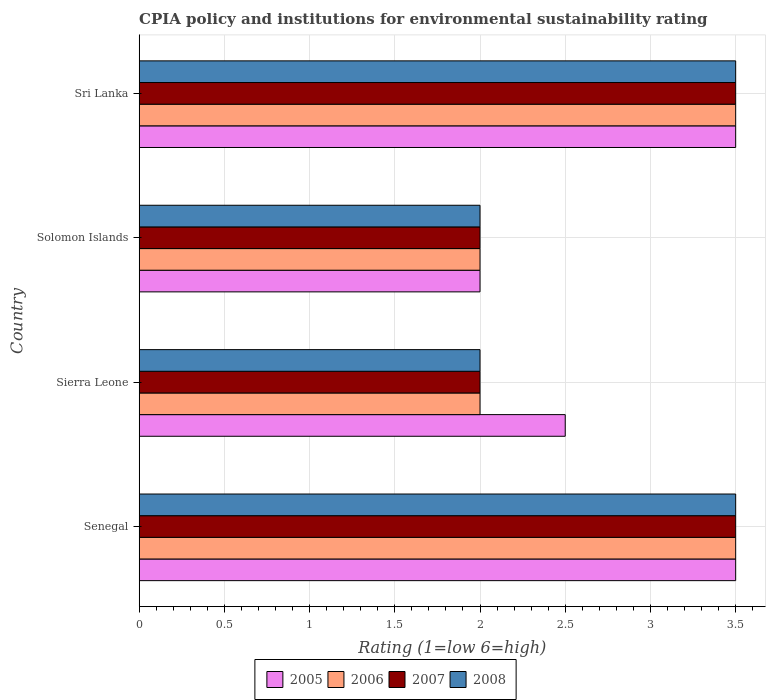How many groups of bars are there?
Give a very brief answer. 4. Are the number of bars per tick equal to the number of legend labels?
Your answer should be very brief. Yes. Are the number of bars on each tick of the Y-axis equal?
Your answer should be compact. Yes. How many bars are there on the 4th tick from the top?
Your response must be concise. 4. How many bars are there on the 4th tick from the bottom?
Give a very brief answer. 4. What is the label of the 4th group of bars from the top?
Ensure brevity in your answer.  Senegal. Across all countries, what is the maximum CPIA rating in 2005?
Offer a terse response. 3.5. In which country was the CPIA rating in 2006 maximum?
Provide a succinct answer. Senegal. In which country was the CPIA rating in 2008 minimum?
Offer a terse response. Sierra Leone. What is the total CPIA rating in 2006 in the graph?
Keep it short and to the point. 11. What is the difference between the CPIA rating in 2008 in Senegal and that in Solomon Islands?
Offer a terse response. 1.5. What is the difference between the CPIA rating in 2006 in Solomon Islands and the CPIA rating in 2008 in Senegal?
Ensure brevity in your answer.  -1.5. What is the average CPIA rating in 2005 per country?
Your answer should be compact. 2.88. What is the difference between the CPIA rating in 2008 and CPIA rating in 2007 in Solomon Islands?
Make the answer very short. 0. In how many countries, is the CPIA rating in 2005 greater than 3.4 ?
Your response must be concise. 2. What is the ratio of the CPIA rating in 2005 in Solomon Islands to that in Sri Lanka?
Offer a terse response. 0.57. Is the difference between the CPIA rating in 2008 in Sierra Leone and Solomon Islands greater than the difference between the CPIA rating in 2007 in Sierra Leone and Solomon Islands?
Make the answer very short. No. What is the difference between the highest and the second highest CPIA rating in 2007?
Offer a terse response. 0. Is the sum of the CPIA rating in 2005 in Senegal and Sierra Leone greater than the maximum CPIA rating in 2006 across all countries?
Provide a succinct answer. Yes. What does the 4th bar from the bottom in Senegal represents?
Ensure brevity in your answer.  2008. How many bars are there?
Your answer should be very brief. 16. Are all the bars in the graph horizontal?
Offer a very short reply. Yes. How many countries are there in the graph?
Keep it short and to the point. 4. What is the difference between two consecutive major ticks on the X-axis?
Give a very brief answer. 0.5. Are the values on the major ticks of X-axis written in scientific E-notation?
Offer a terse response. No. How many legend labels are there?
Ensure brevity in your answer.  4. How are the legend labels stacked?
Provide a short and direct response. Horizontal. What is the title of the graph?
Keep it short and to the point. CPIA policy and institutions for environmental sustainability rating. Does "1987" appear as one of the legend labels in the graph?
Provide a short and direct response. No. What is the label or title of the X-axis?
Provide a short and direct response. Rating (1=low 6=high). What is the Rating (1=low 6=high) in 2005 in Senegal?
Your response must be concise. 3.5. What is the Rating (1=low 6=high) in 2006 in Senegal?
Provide a succinct answer. 3.5. What is the Rating (1=low 6=high) in 2008 in Senegal?
Your answer should be compact. 3.5. What is the Rating (1=low 6=high) of 2005 in Solomon Islands?
Provide a succinct answer. 2. What is the Rating (1=low 6=high) of 2005 in Sri Lanka?
Provide a short and direct response. 3.5. What is the Rating (1=low 6=high) in 2007 in Sri Lanka?
Give a very brief answer. 3.5. What is the Rating (1=low 6=high) of 2008 in Sri Lanka?
Provide a succinct answer. 3.5. Across all countries, what is the maximum Rating (1=low 6=high) in 2008?
Provide a short and direct response. 3.5. Across all countries, what is the minimum Rating (1=low 6=high) of 2006?
Your answer should be compact. 2. Across all countries, what is the minimum Rating (1=low 6=high) in 2007?
Offer a terse response. 2. What is the total Rating (1=low 6=high) in 2005 in the graph?
Your answer should be compact. 11.5. What is the total Rating (1=low 6=high) of 2006 in the graph?
Give a very brief answer. 11. What is the total Rating (1=low 6=high) of 2007 in the graph?
Offer a terse response. 11. What is the total Rating (1=low 6=high) of 2008 in the graph?
Keep it short and to the point. 11. What is the difference between the Rating (1=low 6=high) of 2008 in Senegal and that in Sierra Leone?
Provide a short and direct response. 1.5. What is the difference between the Rating (1=low 6=high) of 2005 in Senegal and that in Solomon Islands?
Make the answer very short. 1.5. What is the difference between the Rating (1=low 6=high) of 2007 in Senegal and that in Solomon Islands?
Provide a short and direct response. 1.5. What is the difference between the Rating (1=low 6=high) in 2008 in Senegal and that in Solomon Islands?
Your answer should be very brief. 1.5. What is the difference between the Rating (1=low 6=high) of 2007 in Senegal and that in Sri Lanka?
Give a very brief answer. 0. What is the difference between the Rating (1=low 6=high) in 2008 in Senegal and that in Sri Lanka?
Offer a very short reply. 0. What is the difference between the Rating (1=low 6=high) in 2006 in Sierra Leone and that in Solomon Islands?
Give a very brief answer. 0. What is the difference between the Rating (1=low 6=high) of 2007 in Sierra Leone and that in Solomon Islands?
Ensure brevity in your answer.  0. What is the difference between the Rating (1=low 6=high) of 2006 in Sierra Leone and that in Sri Lanka?
Provide a succinct answer. -1.5. What is the difference between the Rating (1=low 6=high) in 2008 in Sierra Leone and that in Sri Lanka?
Give a very brief answer. -1.5. What is the difference between the Rating (1=low 6=high) of 2006 in Solomon Islands and that in Sri Lanka?
Ensure brevity in your answer.  -1.5. What is the difference between the Rating (1=low 6=high) of 2007 in Solomon Islands and that in Sri Lanka?
Ensure brevity in your answer.  -1.5. What is the difference between the Rating (1=low 6=high) in 2005 in Senegal and the Rating (1=low 6=high) in 2006 in Sierra Leone?
Offer a very short reply. 1.5. What is the difference between the Rating (1=low 6=high) of 2005 in Senegal and the Rating (1=low 6=high) of 2008 in Sierra Leone?
Your answer should be very brief. 1.5. What is the difference between the Rating (1=low 6=high) of 2006 in Senegal and the Rating (1=low 6=high) of 2007 in Sierra Leone?
Provide a short and direct response. 1.5. What is the difference between the Rating (1=low 6=high) in 2007 in Senegal and the Rating (1=low 6=high) in 2008 in Sierra Leone?
Ensure brevity in your answer.  1.5. What is the difference between the Rating (1=low 6=high) in 2005 in Senegal and the Rating (1=low 6=high) in 2007 in Solomon Islands?
Your answer should be compact. 1.5. What is the difference between the Rating (1=low 6=high) in 2006 in Senegal and the Rating (1=low 6=high) in 2008 in Solomon Islands?
Make the answer very short. 1.5. What is the difference between the Rating (1=low 6=high) of 2007 in Senegal and the Rating (1=low 6=high) of 2008 in Solomon Islands?
Your response must be concise. 1.5. What is the difference between the Rating (1=low 6=high) of 2005 in Senegal and the Rating (1=low 6=high) of 2008 in Sri Lanka?
Give a very brief answer. 0. What is the difference between the Rating (1=low 6=high) in 2005 in Sierra Leone and the Rating (1=low 6=high) in 2006 in Solomon Islands?
Provide a short and direct response. 0.5. What is the difference between the Rating (1=low 6=high) in 2006 in Sierra Leone and the Rating (1=low 6=high) in 2008 in Solomon Islands?
Offer a terse response. 0. What is the difference between the Rating (1=low 6=high) in 2007 in Sierra Leone and the Rating (1=low 6=high) in 2008 in Solomon Islands?
Give a very brief answer. 0. What is the difference between the Rating (1=low 6=high) in 2006 in Sierra Leone and the Rating (1=low 6=high) in 2007 in Sri Lanka?
Offer a terse response. -1.5. What is the difference between the Rating (1=low 6=high) of 2006 in Sierra Leone and the Rating (1=low 6=high) of 2008 in Sri Lanka?
Your response must be concise. -1.5. What is the difference between the Rating (1=low 6=high) of 2007 in Sierra Leone and the Rating (1=low 6=high) of 2008 in Sri Lanka?
Offer a very short reply. -1.5. What is the difference between the Rating (1=low 6=high) in 2005 in Solomon Islands and the Rating (1=low 6=high) in 2008 in Sri Lanka?
Your answer should be compact. -1.5. What is the difference between the Rating (1=low 6=high) of 2006 in Solomon Islands and the Rating (1=low 6=high) of 2007 in Sri Lanka?
Offer a very short reply. -1.5. What is the difference between the Rating (1=low 6=high) in 2006 in Solomon Islands and the Rating (1=low 6=high) in 2008 in Sri Lanka?
Your response must be concise. -1.5. What is the difference between the Rating (1=low 6=high) in 2007 in Solomon Islands and the Rating (1=low 6=high) in 2008 in Sri Lanka?
Keep it short and to the point. -1.5. What is the average Rating (1=low 6=high) of 2005 per country?
Your answer should be very brief. 2.88. What is the average Rating (1=low 6=high) of 2006 per country?
Keep it short and to the point. 2.75. What is the average Rating (1=low 6=high) of 2007 per country?
Keep it short and to the point. 2.75. What is the average Rating (1=low 6=high) of 2008 per country?
Your answer should be compact. 2.75. What is the difference between the Rating (1=low 6=high) of 2005 and Rating (1=low 6=high) of 2006 in Senegal?
Ensure brevity in your answer.  0. What is the difference between the Rating (1=low 6=high) of 2005 and Rating (1=low 6=high) of 2007 in Senegal?
Keep it short and to the point. 0. What is the difference between the Rating (1=low 6=high) in 2006 and Rating (1=low 6=high) in 2008 in Senegal?
Offer a very short reply. 0. What is the difference between the Rating (1=low 6=high) of 2007 and Rating (1=low 6=high) of 2008 in Senegal?
Your answer should be compact. 0. What is the difference between the Rating (1=low 6=high) in 2005 and Rating (1=low 6=high) in 2006 in Sierra Leone?
Provide a succinct answer. 0.5. What is the difference between the Rating (1=low 6=high) in 2005 and Rating (1=low 6=high) in 2007 in Sierra Leone?
Provide a succinct answer. 0.5. What is the difference between the Rating (1=low 6=high) in 2005 and Rating (1=low 6=high) in 2008 in Sierra Leone?
Your response must be concise. 0.5. What is the difference between the Rating (1=low 6=high) of 2006 and Rating (1=low 6=high) of 2007 in Sierra Leone?
Keep it short and to the point. 0. What is the difference between the Rating (1=low 6=high) in 2007 and Rating (1=low 6=high) in 2008 in Sierra Leone?
Keep it short and to the point. 0. What is the difference between the Rating (1=low 6=high) in 2005 and Rating (1=low 6=high) in 2006 in Solomon Islands?
Offer a terse response. 0. What is the difference between the Rating (1=low 6=high) of 2005 and Rating (1=low 6=high) of 2008 in Solomon Islands?
Offer a terse response. 0. What is the difference between the Rating (1=low 6=high) of 2006 and Rating (1=low 6=high) of 2007 in Solomon Islands?
Provide a succinct answer. 0. What is the difference between the Rating (1=low 6=high) in 2007 and Rating (1=low 6=high) in 2008 in Solomon Islands?
Ensure brevity in your answer.  0. What is the difference between the Rating (1=low 6=high) of 2005 and Rating (1=low 6=high) of 2007 in Sri Lanka?
Ensure brevity in your answer.  0. What is the difference between the Rating (1=low 6=high) in 2005 and Rating (1=low 6=high) in 2008 in Sri Lanka?
Your response must be concise. 0. What is the difference between the Rating (1=low 6=high) in 2006 and Rating (1=low 6=high) in 2007 in Sri Lanka?
Your response must be concise. 0. What is the difference between the Rating (1=low 6=high) in 2006 and Rating (1=low 6=high) in 2008 in Sri Lanka?
Give a very brief answer. 0. What is the ratio of the Rating (1=low 6=high) of 2007 in Senegal to that in Sierra Leone?
Provide a short and direct response. 1.75. What is the ratio of the Rating (1=low 6=high) of 2008 in Senegal to that in Solomon Islands?
Keep it short and to the point. 1.75. What is the ratio of the Rating (1=low 6=high) of 2005 in Senegal to that in Sri Lanka?
Your response must be concise. 1. What is the ratio of the Rating (1=low 6=high) in 2007 in Senegal to that in Sri Lanka?
Your answer should be very brief. 1. What is the ratio of the Rating (1=low 6=high) of 2008 in Senegal to that in Sri Lanka?
Your response must be concise. 1. What is the ratio of the Rating (1=low 6=high) of 2006 in Sierra Leone to that in Solomon Islands?
Keep it short and to the point. 1. What is the ratio of the Rating (1=low 6=high) in 2007 in Sierra Leone to that in Solomon Islands?
Keep it short and to the point. 1. What is the ratio of the Rating (1=low 6=high) in 2008 in Sierra Leone to that in Solomon Islands?
Offer a terse response. 1. What is the ratio of the Rating (1=low 6=high) in 2006 in Sierra Leone to that in Sri Lanka?
Provide a short and direct response. 0.57. What is the ratio of the Rating (1=low 6=high) of 2007 in Sierra Leone to that in Sri Lanka?
Keep it short and to the point. 0.57. What is the ratio of the Rating (1=low 6=high) in 2008 in Sierra Leone to that in Sri Lanka?
Provide a succinct answer. 0.57. What is the ratio of the Rating (1=low 6=high) in 2005 in Solomon Islands to that in Sri Lanka?
Ensure brevity in your answer.  0.57. What is the ratio of the Rating (1=low 6=high) of 2008 in Solomon Islands to that in Sri Lanka?
Provide a succinct answer. 0.57. What is the difference between the highest and the second highest Rating (1=low 6=high) in 2006?
Your answer should be compact. 0. What is the difference between the highest and the second highest Rating (1=low 6=high) in 2008?
Offer a terse response. 0. What is the difference between the highest and the lowest Rating (1=low 6=high) in 2005?
Ensure brevity in your answer.  1.5. What is the difference between the highest and the lowest Rating (1=low 6=high) in 2006?
Ensure brevity in your answer.  1.5. 